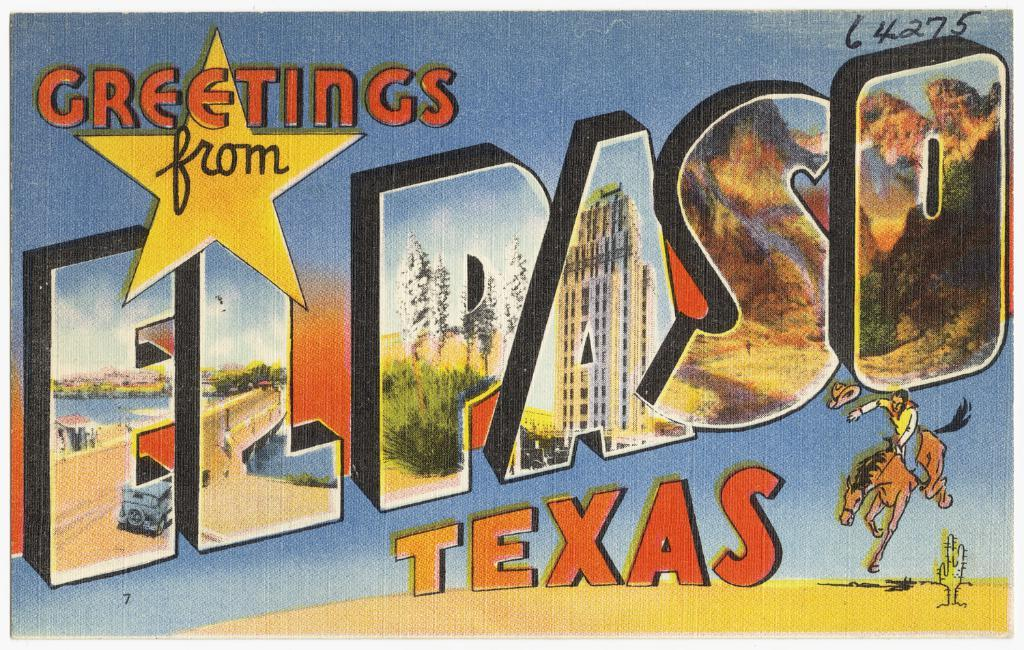<image>
Render a clear and concise summary of the photo. A picture of a post card from El Paso Texas. 